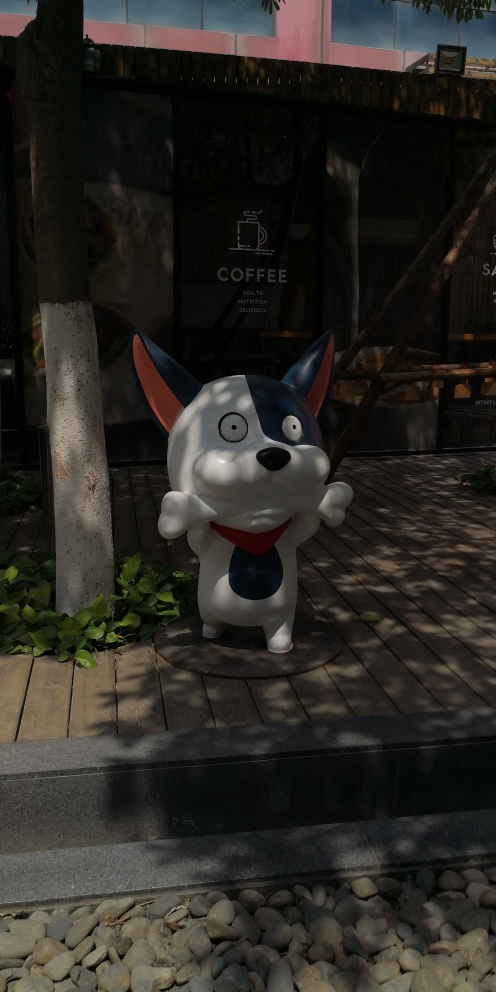What might be the purpose of this figure in front of the coffee shop? The figure in the image appears to be designed for promotional purposes, likely meant to attract attention towards the coffee shop. Its cartoonish style and exaggerated expressiveness suggest it is aimed at appealing to a younger demographic or to create a friendly, welcoming atmosphere around the shop. What elements in the background can you tell me more about? The background features a partially shaded coffee shop façade with a clear logo that advertises coffee. Trees partially obscure the upper parts of the building, providing a natural contrasting frame to the artificial, playful foreground. The sliding wooden frames suggest a semi-outdoor seating area, possibly enhancing the café's cozy, earthy feel. 